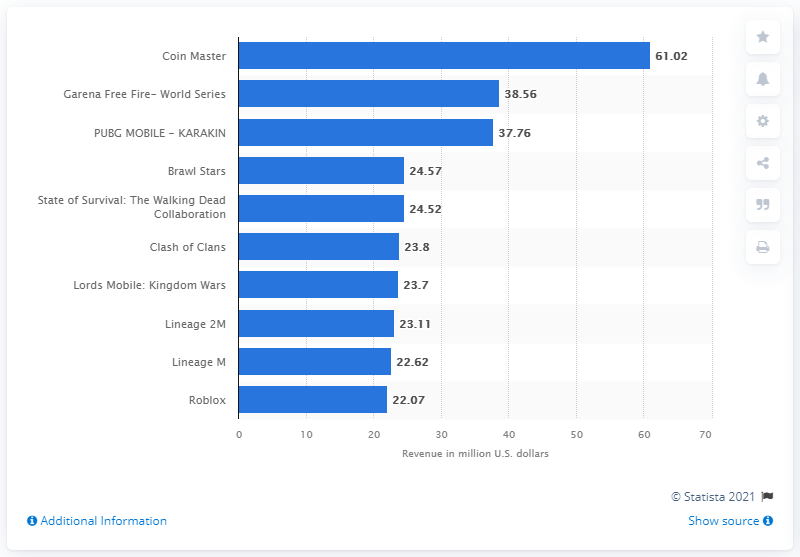Indicate a few pertinent items in this graphic. According to a report, the mobile app "Coin Master" generated 61.02 million U.S. dollars in global revenues through the Google Play Store in April 2021. In April 2021, Coin Master generated approximately $61.02 million in the U.S. 